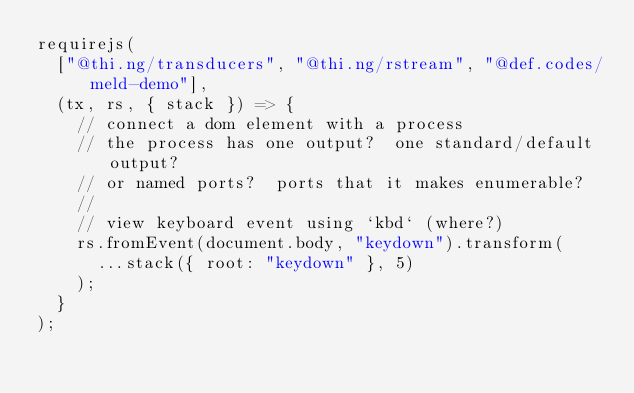<code> <loc_0><loc_0><loc_500><loc_500><_JavaScript_>requirejs(
  ["@thi.ng/transducers", "@thi.ng/rstream", "@def.codes/meld-demo"],
  (tx, rs, { stack }) => {
    // connect a dom element with a process
    // the process has one output?  one standard/default output?
    // or named ports?  ports that it makes enumerable?
    //
    // view keyboard event using `kbd` (where?)
    rs.fromEvent(document.body, "keydown").transform(
      ...stack({ root: "keydown" }, 5)
    );
  }
);
</code> 